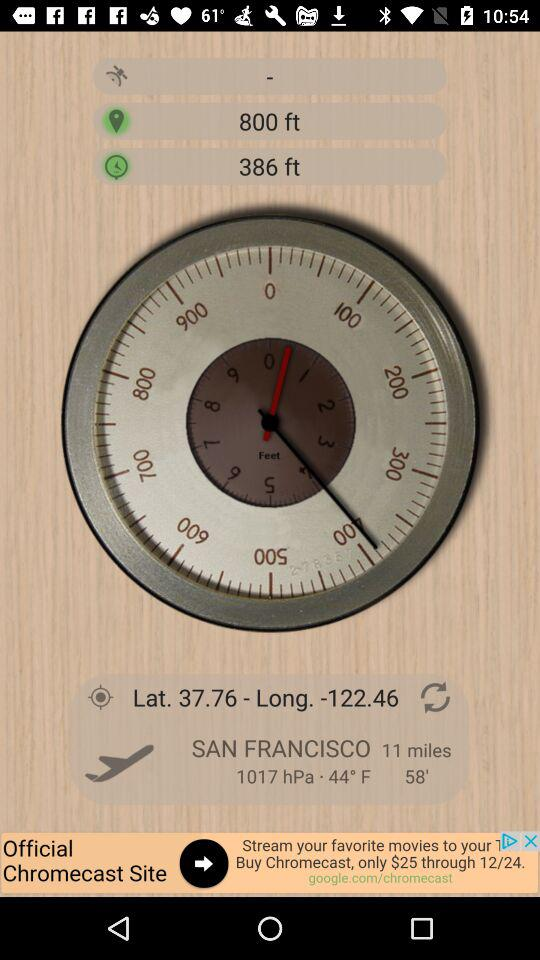What time is it in San Francisco?
When the provided information is insufficient, respond with <no answer>. <no answer> 